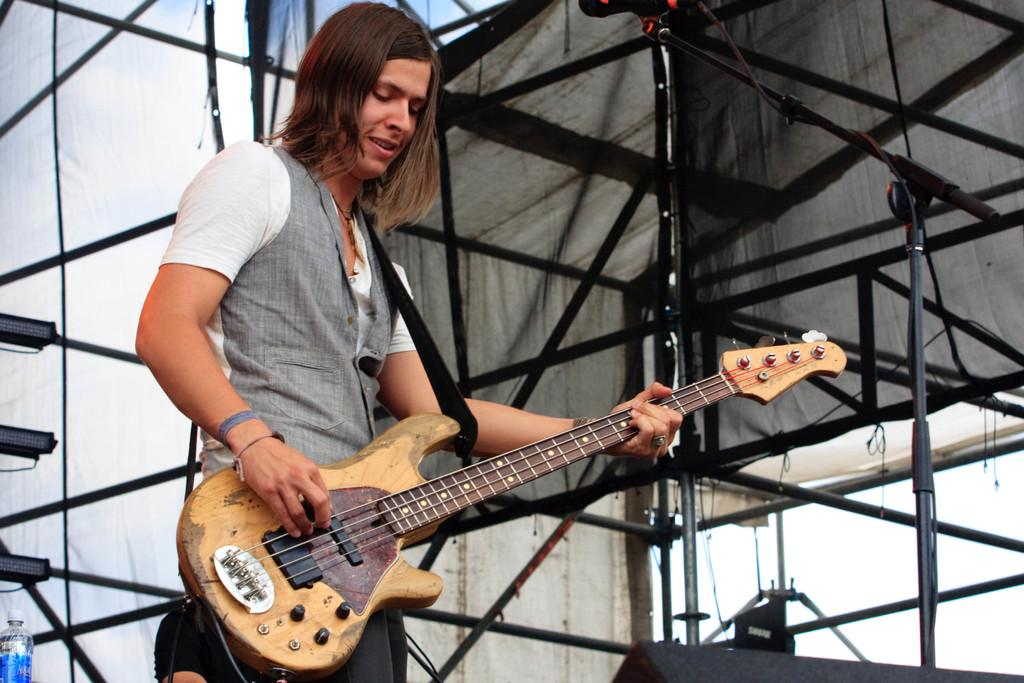What is the person in the image doing? The person is standing in the image and holding a guitar. What object is the person holding in the image? The person is holding a guitar. What can be seen in the background of the image? There is a stand of iron rods in the background of the image. What type of advertisement can be seen on the stove in the image? There is no stove or advertisement present in the image. 